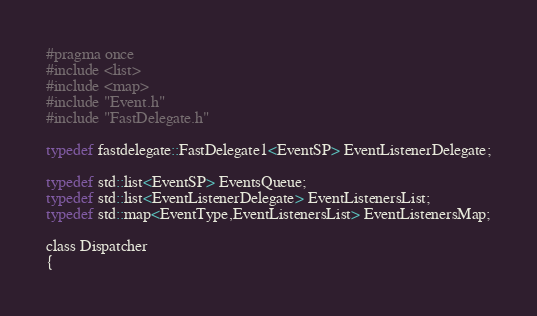Convert code to text. <code><loc_0><loc_0><loc_500><loc_500><_C_>#pragma once
#include <list>
#include <map>
#include "Event.h"
#include "FastDelegate.h"

typedef fastdelegate::FastDelegate1<EventSP> EventListenerDelegate;

typedef std::list<EventSP> EventsQueue;
typedef std::list<EventListenerDelegate> EventListenersList;
typedef std::map<EventType,EventListenersList> EventListenersMap;

class Dispatcher
{</code> 